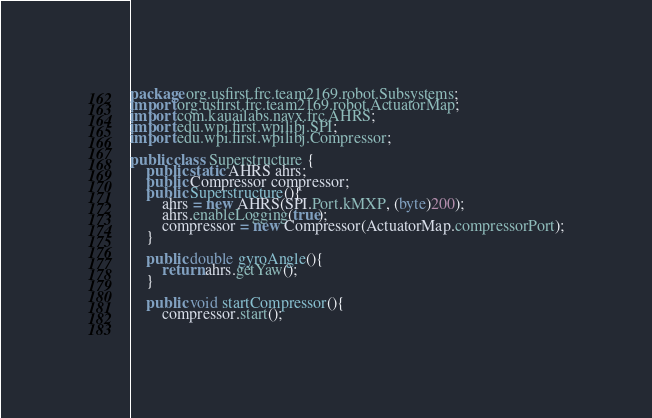<code> <loc_0><loc_0><loc_500><loc_500><_Java_>package org.usfirst.frc.team2169.robot.Subsystems;
import org.usfirst.frc.team2169.robot.ActuatorMap;
import com.kauailabs.navx.frc.AHRS;
import edu.wpi.first.wpilibj.SPI;
import edu.wpi.first.wpilibj.Compressor;

public class Superstructure {
	public static AHRS ahrs;
	public Compressor compressor;
	public Superstructure(){
		ahrs = new AHRS(SPI.Port.kMXP, (byte)200);
		ahrs.enableLogging(true);
		compressor = new Compressor(ActuatorMap.compressorPort);
	}

	public double gyroAngle(){
		return ahrs.getYaw();
	}
	
	public void startCompressor(){
		compressor.start();
		</code> 